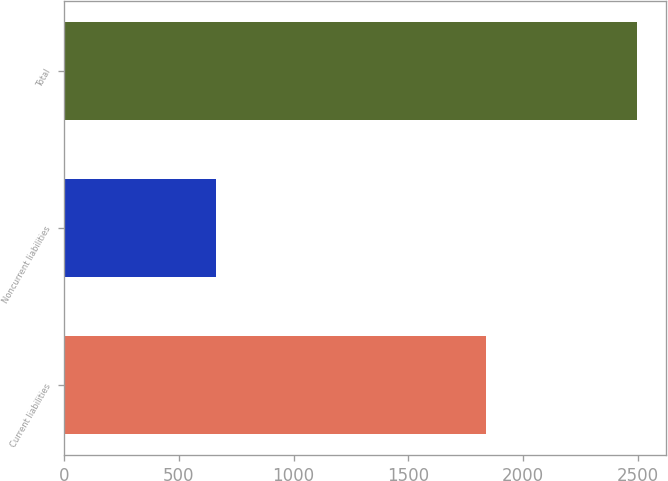Convert chart. <chart><loc_0><loc_0><loc_500><loc_500><bar_chart><fcel>Current liabilities<fcel>Noncurrent liabilities<fcel>Total<nl><fcel>1836<fcel>660<fcel>2496<nl></chart> 